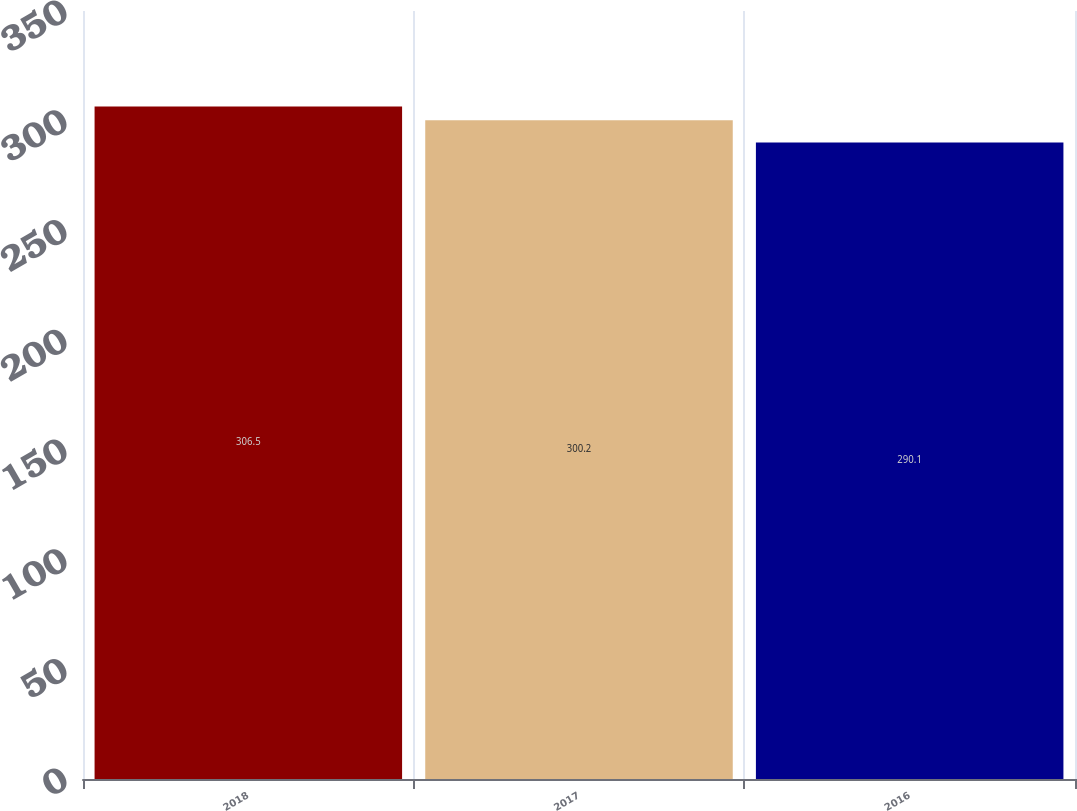<chart> <loc_0><loc_0><loc_500><loc_500><bar_chart><fcel>2018<fcel>2017<fcel>2016<nl><fcel>306.5<fcel>300.2<fcel>290.1<nl></chart> 